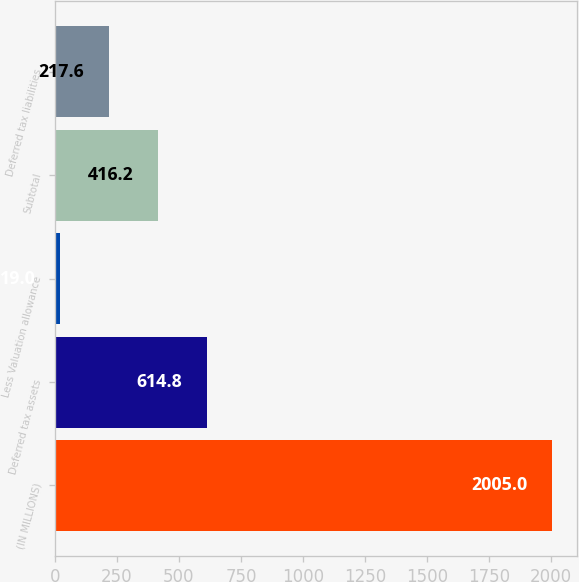<chart> <loc_0><loc_0><loc_500><loc_500><bar_chart><fcel>(IN MILLIONS)<fcel>Deferred tax assets<fcel>Less Valuation allowance<fcel>Subtotal<fcel>Deferred tax liabilities<nl><fcel>2005<fcel>614.8<fcel>19<fcel>416.2<fcel>217.6<nl></chart> 